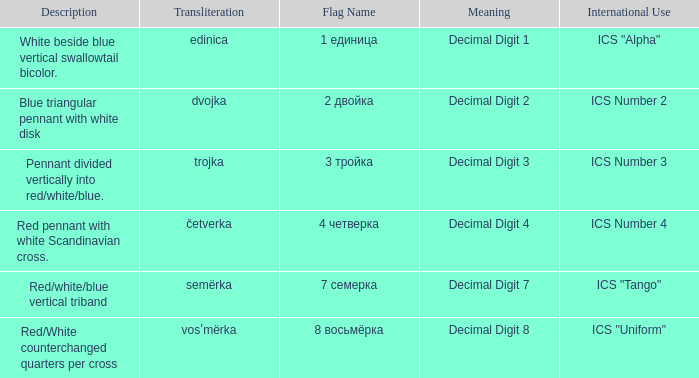Would you mind parsing the complete table? {'header': ['Description', 'Transliteration', 'Flag Name', 'Meaning', 'International Use'], 'rows': [['White beside blue vertical swallowtail bicolor.', 'edinica', '1 единица', 'Decimal Digit 1', 'ICS "Alpha"'], ['Blue triangular pennant with white disk', 'dvojka', '2 двойка', 'Decimal Digit 2', 'ICS Number 2'], ['Pennant divided vertically into red/white/blue.', 'trojka', '3 тройка', 'Decimal Digit 3', 'ICS Number 3'], ['Red pennant with white Scandinavian cross.', 'četverka', '4 четверка', 'Decimal Digit 4', 'ICS Number 4'], ['Red/white/blue vertical triband', 'semërka', '7 семерка', 'Decimal Digit 7', 'ICS "Tango"'], ['Red/White counterchanged quarters per cross', 'vosʹmërka', '8 восьмёрка', 'Decimal Digit 8', 'ICS "Uniform"']]} What is the name of the flag that means decimal digit 2? 2 двойка. 